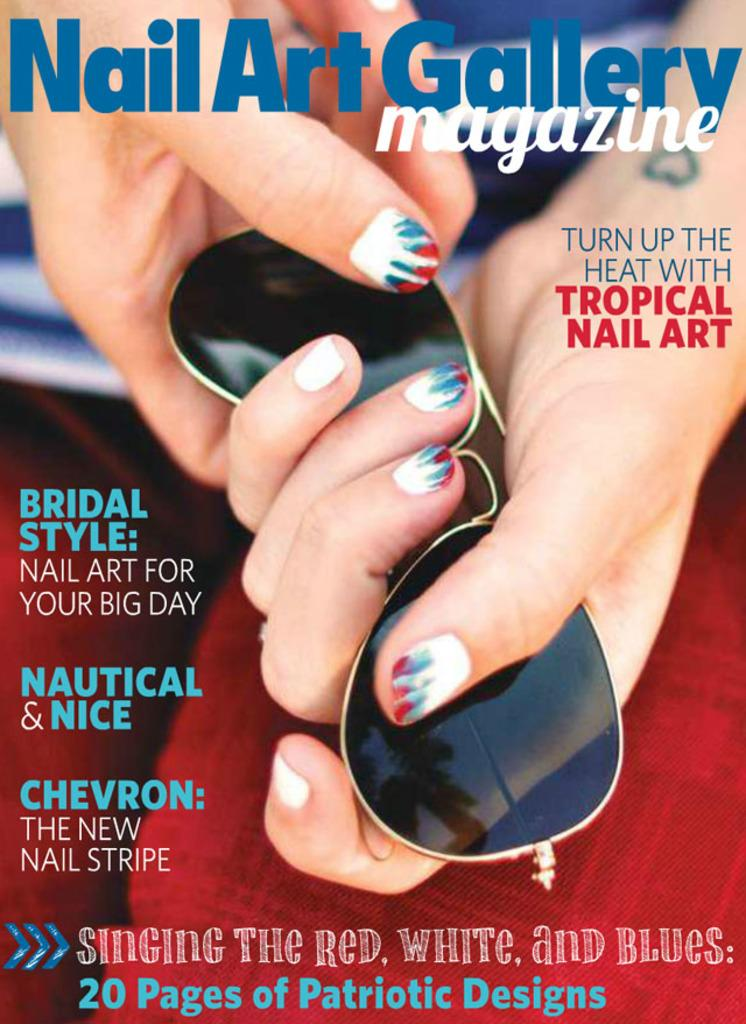<image>
Share a concise interpretation of the image provided. A Nail Art Gallery Magazine cover with a picture of a woman's hand with red, white and blue manicured nails holding a pair of Wayfair sunglasses. 